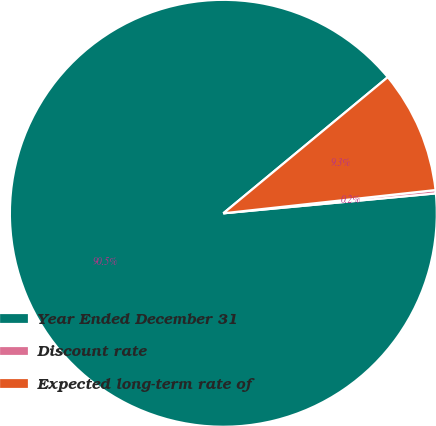<chart> <loc_0><loc_0><loc_500><loc_500><pie_chart><fcel>Year Ended December 31<fcel>Discount rate<fcel>Expected long-term rate of<nl><fcel>90.48%<fcel>0.25%<fcel>9.27%<nl></chart> 